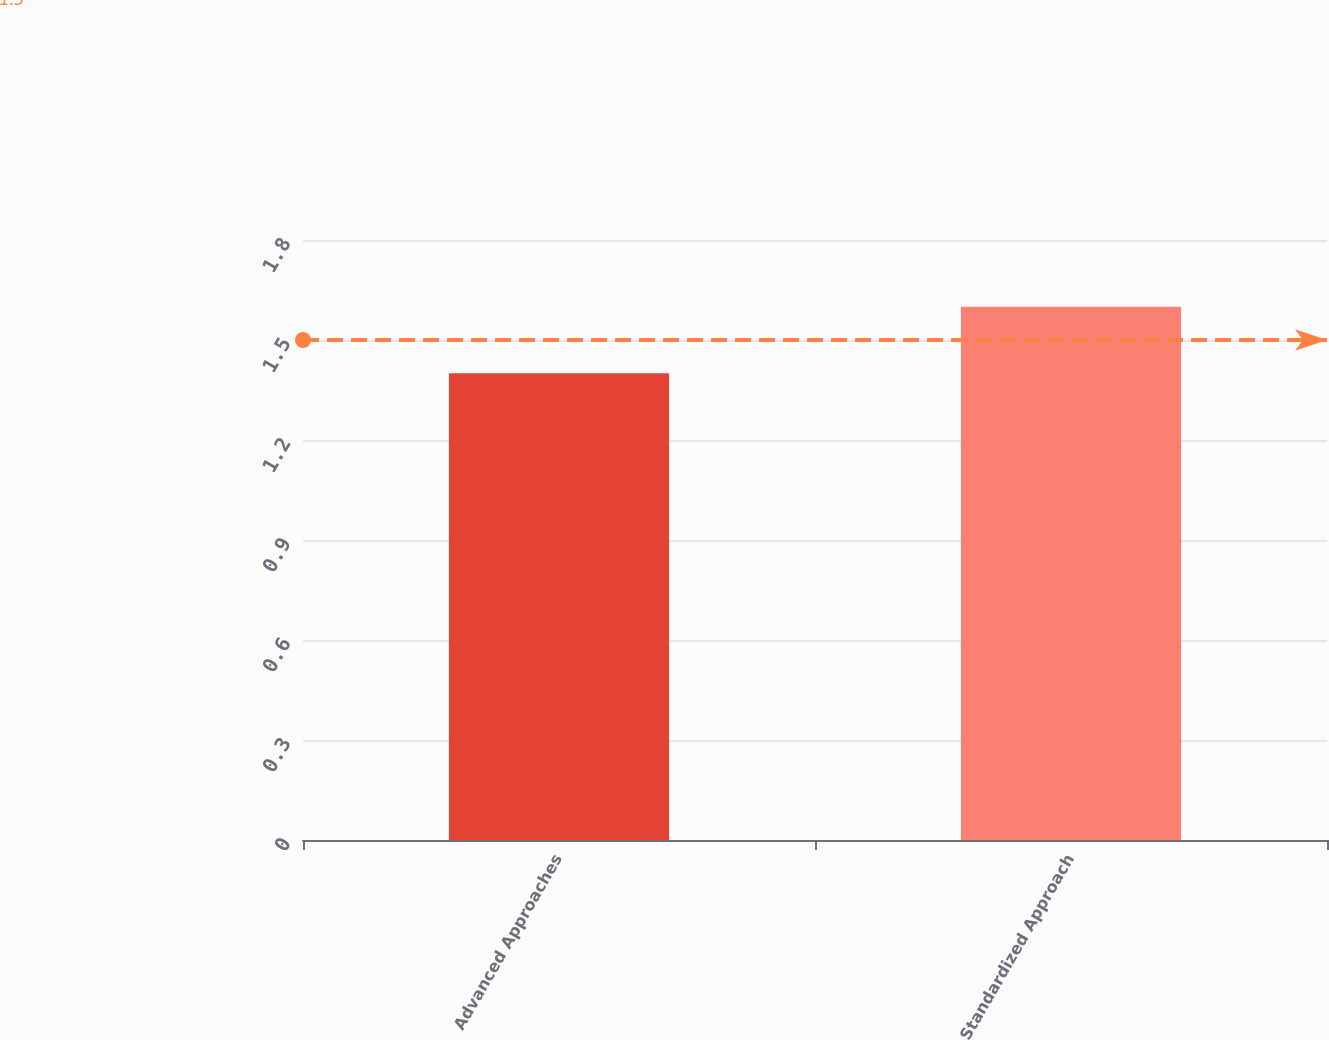Convert chart to OTSL. <chart><loc_0><loc_0><loc_500><loc_500><bar_chart><fcel>Advanced Approaches<fcel>Standardized Approach<nl><fcel>1.4<fcel>1.6<nl></chart> 